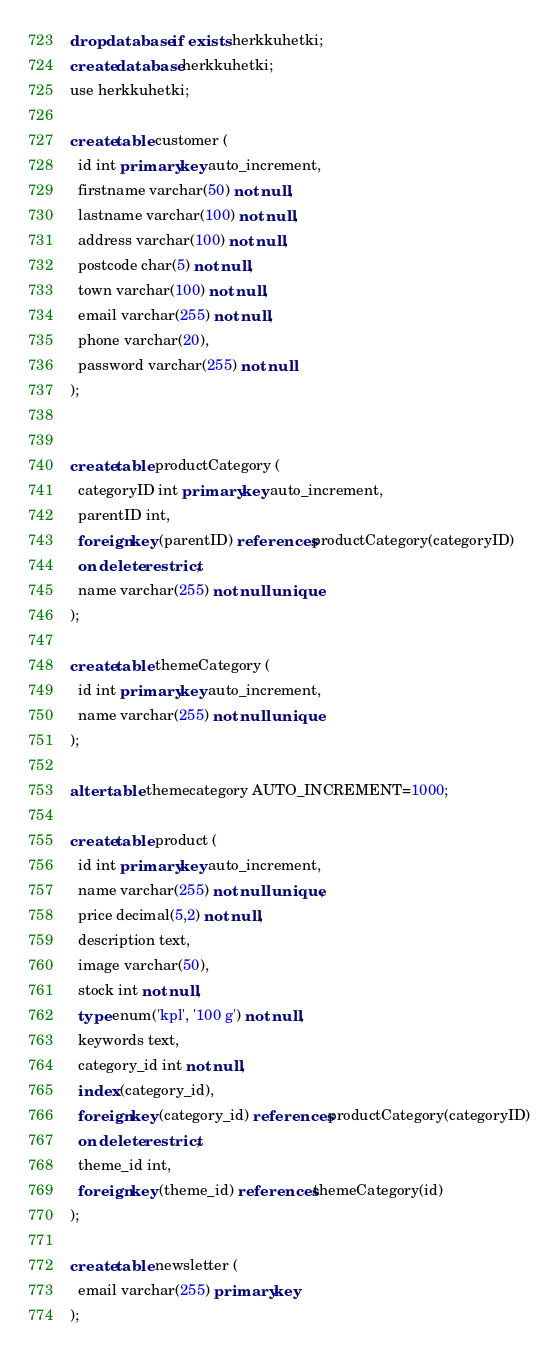Convert code to text. <code><loc_0><loc_0><loc_500><loc_500><_SQL_>drop database if exists herkkuhetki;
create database herkkuhetki;
use herkkuhetki;

create table customer (
  id int primary key auto_increment,
  firstname varchar(50) not null,
  lastname varchar(100) not null,
  address varchar(100) not null,
  postcode char(5) not null,
  town varchar(100) not null,
  email varchar(255) not null,
  phone varchar(20),
  password varchar(255) not null
);


create table productCategory (
  categoryID int primary key auto_increment,
  parentID int,
  foreign key (parentID) references productCategory(categoryID)
  on delete restrict,
  name varchar(255) not null unique
);

create table themeCategory (
  id int primary key auto_increment,
  name varchar(255) not null unique
);

alter table themecategory AUTO_INCREMENT=1000;

create table product (
  id int primary key auto_increment,
  name varchar(255) not null unique,
  price decimal(5,2) not null,
  description text,
  image varchar(50),
  stock int not null,
  type enum('kpl', '100 g') not null,
  keywords text,
  category_id int not null,
  index (category_id),
  foreign key (category_id) references productCategory(categoryID)
  on delete restrict,
  theme_id int,
  foreign key (theme_id) references themeCategory(id)
);

create table newsletter (
  email varchar(255) primary key
);
</code> 